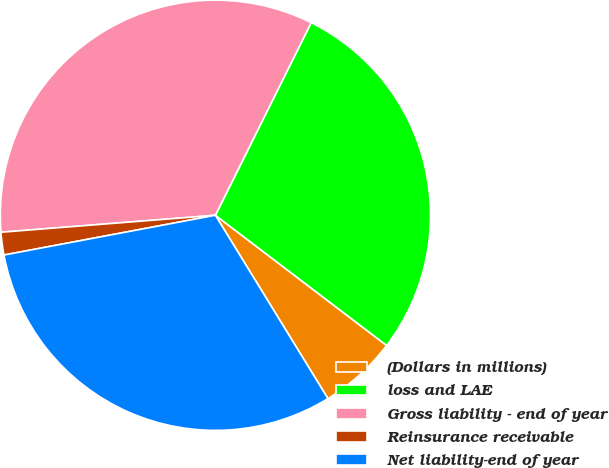Convert chart to OTSL. <chart><loc_0><loc_0><loc_500><loc_500><pie_chart><fcel>(Dollars in millions)<fcel>loss and LAE<fcel>Gross liability - end of year<fcel>Reinsurance receivable<fcel>Net liability-end of year<nl><fcel>5.89%<fcel>28.0%<fcel>33.6%<fcel>1.7%<fcel>30.8%<nl></chart> 